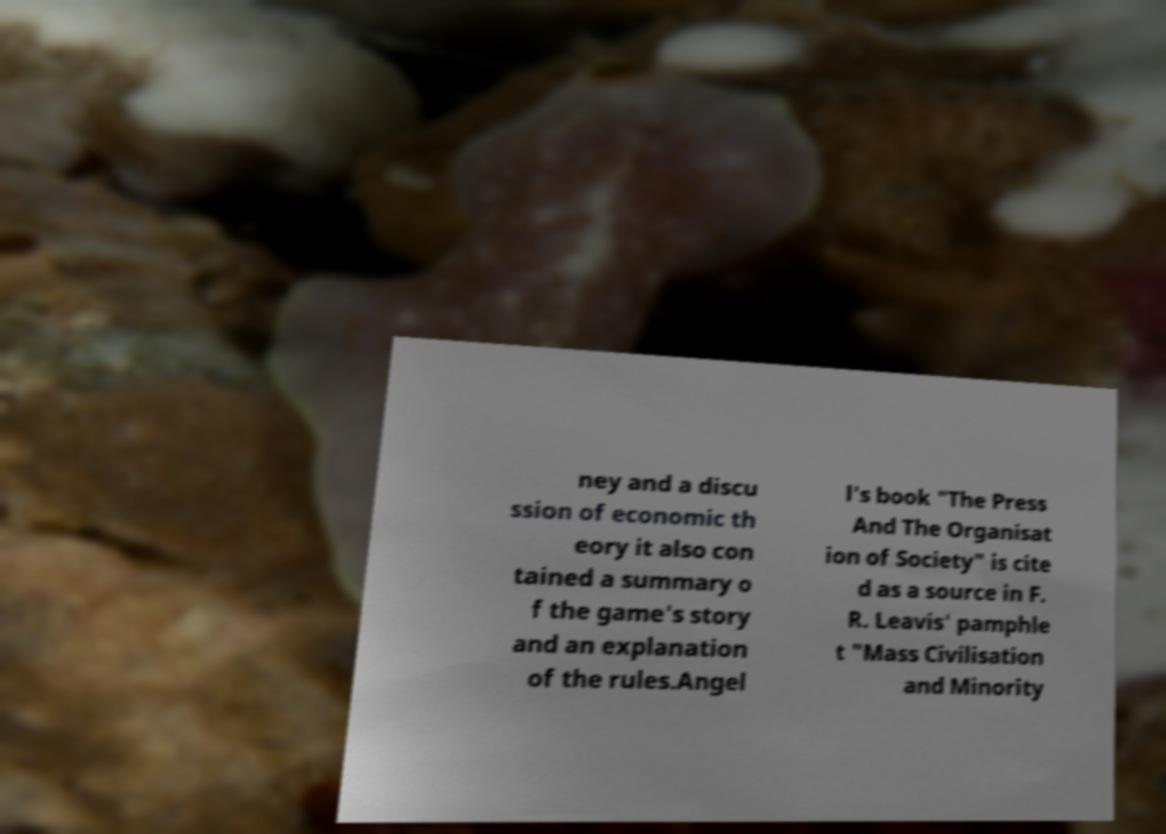There's text embedded in this image that I need extracted. Can you transcribe it verbatim? ney and a discu ssion of economic th eory it also con tained a summary o f the game's story and an explanation of the rules.Angel l's book "The Press And The Organisat ion of Society" is cite d as a source in F. R. Leavis' pamphle t "Mass Civilisation and Minority 